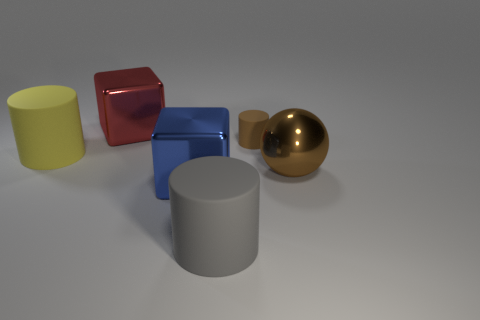Subtract all big cylinders. How many cylinders are left? 1 Add 3 shiny balls. How many objects exist? 9 Subtract all yellow cylinders. How many cylinders are left? 2 Subtract all cubes. How many objects are left? 4 Subtract all tiny blue metallic blocks. Subtract all metallic blocks. How many objects are left? 4 Add 3 big brown objects. How many big brown objects are left? 4 Add 1 brown matte things. How many brown matte things exist? 2 Subtract 0 purple balls. How many objects are left? 6 Subtract all blue blocks. Subtract all gray spheres. How many blocks are left? 1 